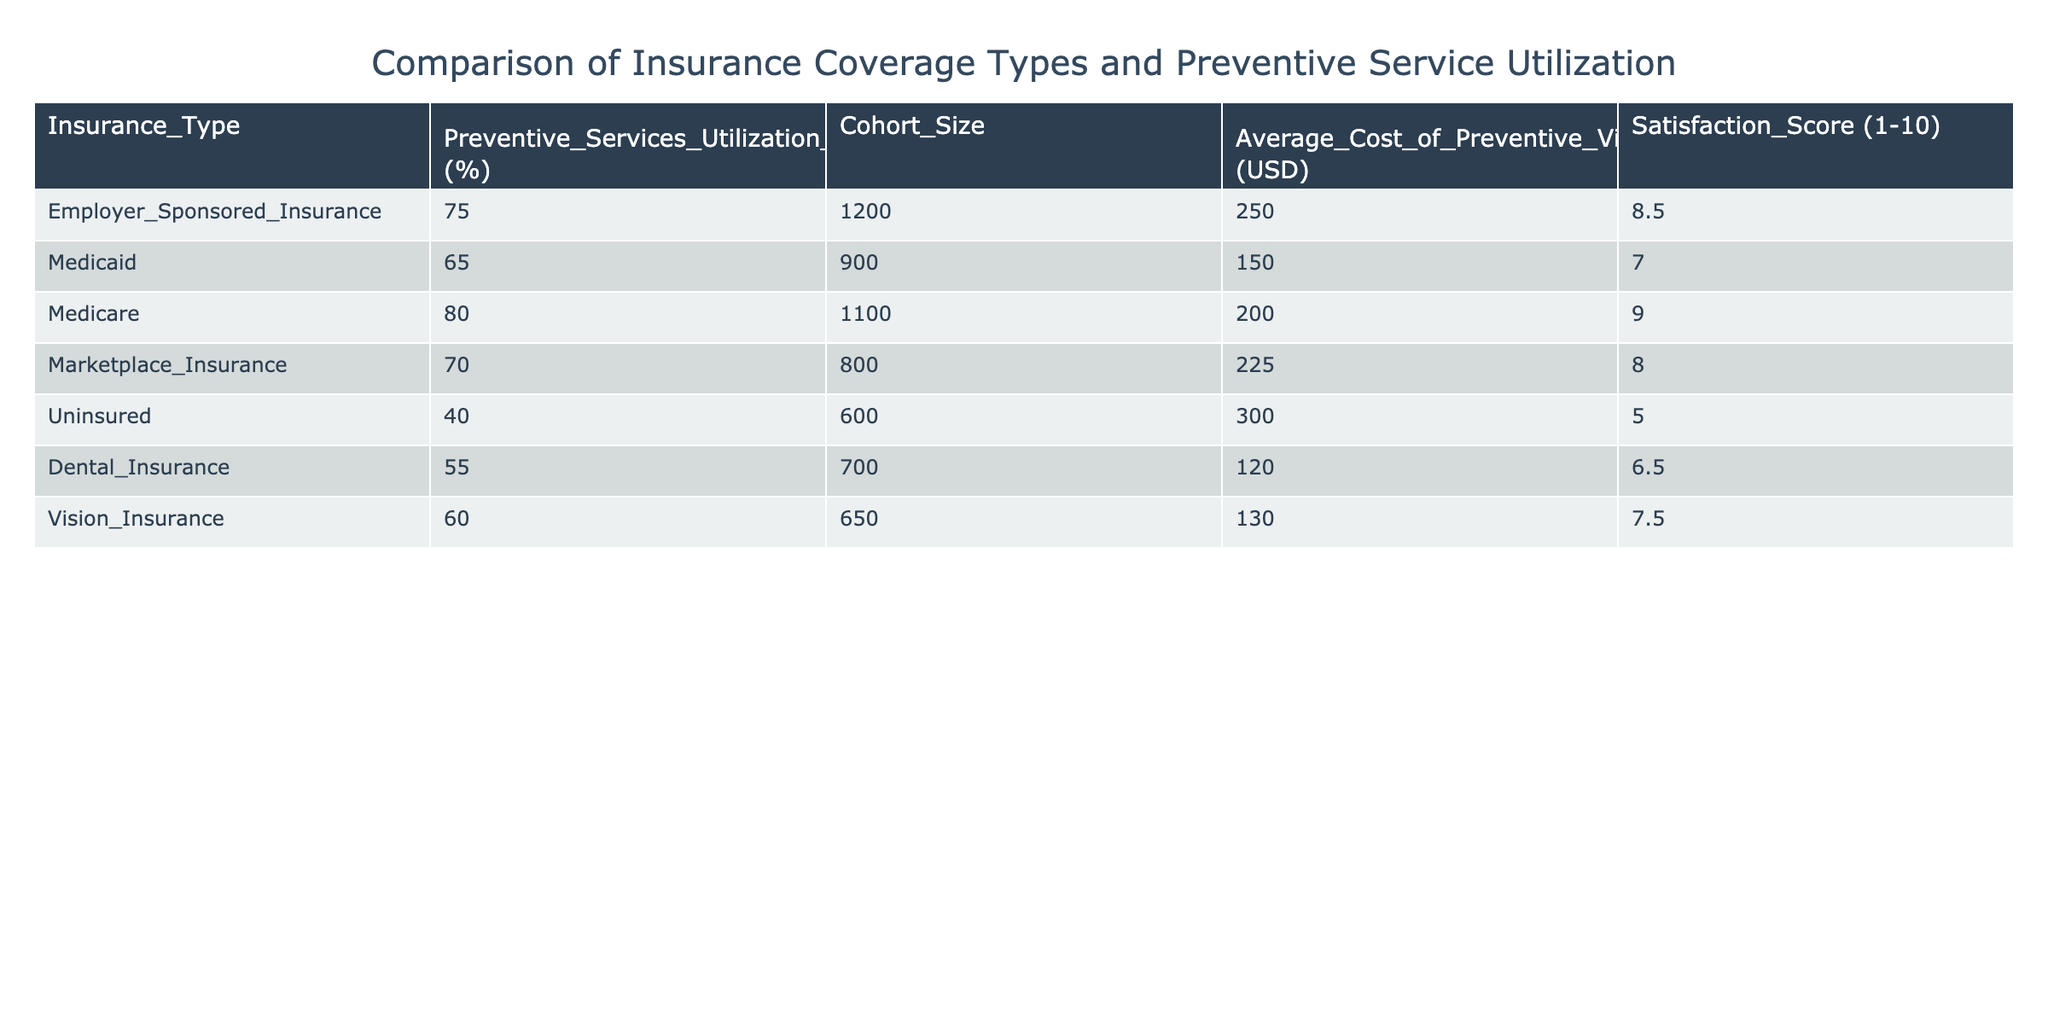What is the preventive services utilization rate for Medicare? The table lists a preventive services utilization rate of 80% for Medicare, which can be directly found in the corresponding row under the column "Preventive_Services_Utilization_Rate (%)".
Answer: 80% Which insurance type has the highest satisfaction score? The table shows that Medicare has the highest satisfaction score at 9.0, which is explicitly stated in the "Satisfaction_Score (1-10)" column.
Answer: Medicare What is the difference in average cost of preventive visits between Employer Sponsored Insurance and Medicaid? The average cost for Employer Sponsored Insurance is $250 and for Medicaid it is $150. The difference is calculated as $250 - $150 = $100.
Answer: 100 Is the preventive services utilization rate for the uninsured higher than for those with Marketplace Insurance? The table states that the utilization rate for the uninsured is 40% and for Marketplace Insurance it is 70%. Since 40% is less than 70%, the answer to the question is no.
Answer: No What is the average preventive services utilization rate for all insurance types listed? To find the average, we sum all utilization rates: (75 + 65 + 80 + 70 + 40 + 55 + 60) = 415. There are 7 types of insurance, so the average is 415 / 7 = 59.29.
Answer: 59.29 Which insurance type has the lowest cohort size? Looking through the “Cohort_Size” column, the lowest cohort size is 600, which corresponds to the Uninsured category.
Answer: Uninsured What is the average satisfaction score for those with employer-sponsored and marketplace insurance? The satisfaction score for Employer Sponsored Insurance is 8.5, and for Marketplace Insurance, it is 8.0. Adding these scores gives 8.5 + 8.0 = 16.5. Dividing by 2 gives an average of 8.25.
Answer: 8.25 Is it true that the average cost of preventive visits is below $200 for any insurance type? The average costs for each type are: Employer Sponsored Insurance ($250), Medicaid ($150), Medicare ($200), Marketplace Insurance ($225), Uninsured ($300), Dental Insurance ($120), and Vision Insurance ($130). The only types below $200 are Medicaid, Dental Insurance, and Vision Insurance, hence the statement is true.
Answer: Yes 